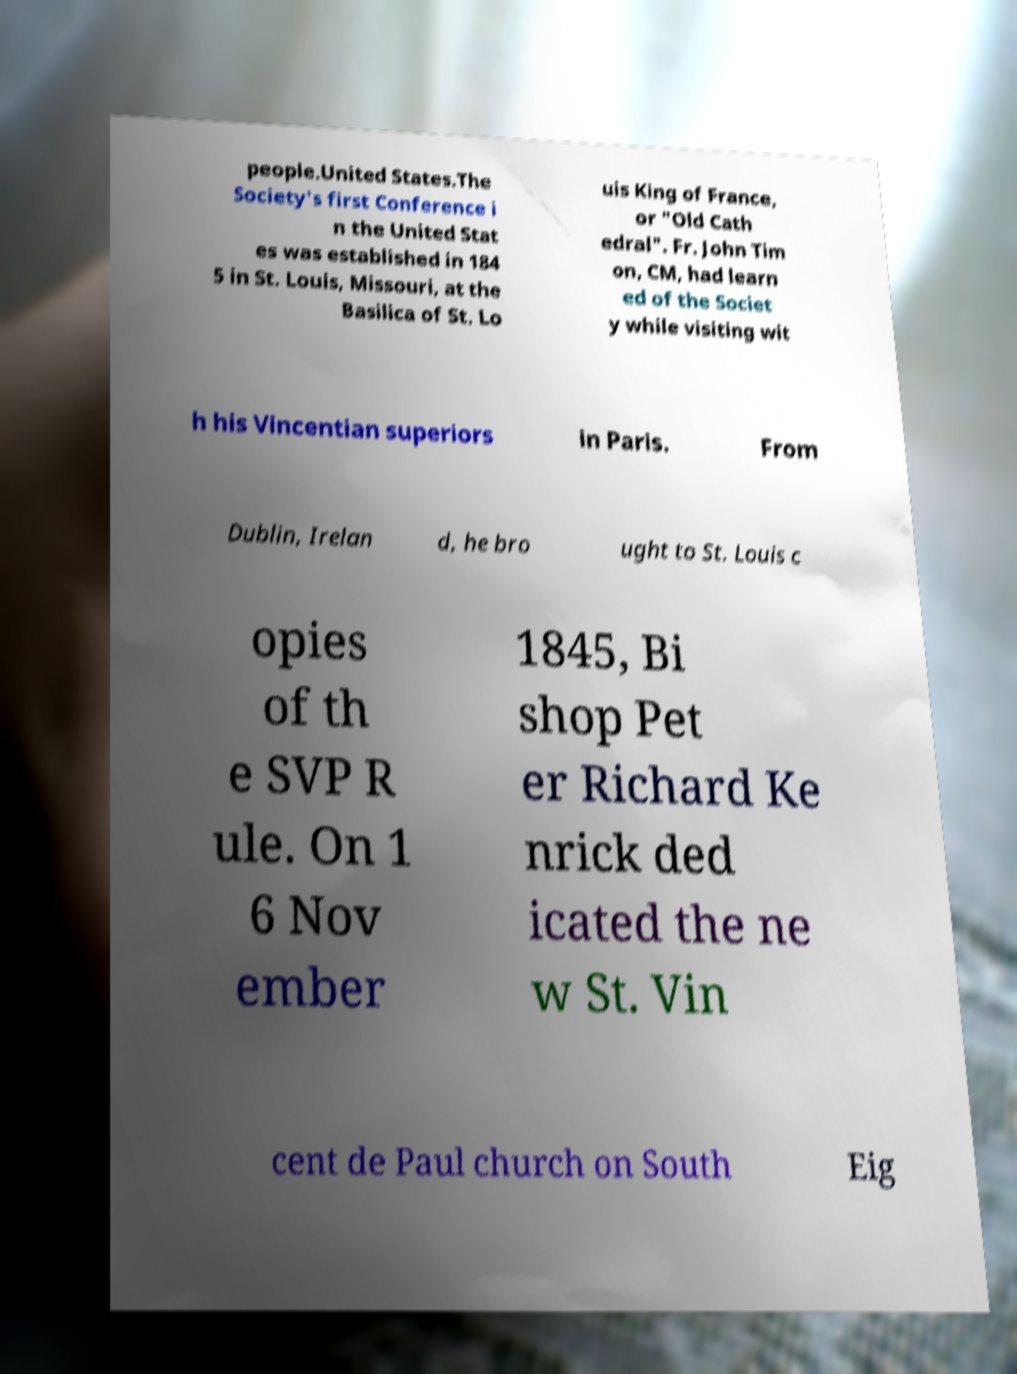Please identify and transcribe the text found in this image. people.United States.The Society's first Conference i n the United Stat es was established in 184 5 in St. Louis, Missouri, at the Basilica of St. Lo uis King of France, or "Old Cath edral". Fr. John Tim on, CM, had learn ed of the Societ y while visiting wit h his Vincentian superiors in Paris. From Dublin, Irelan d, he bro ught to St. Louis c opies of th e SVP R ule. On 1 6 Nov ember 1845, Bi shop Pet er Richard Ke nrick ded icated the ne w St. Vin cent de Paul church on South Eig 